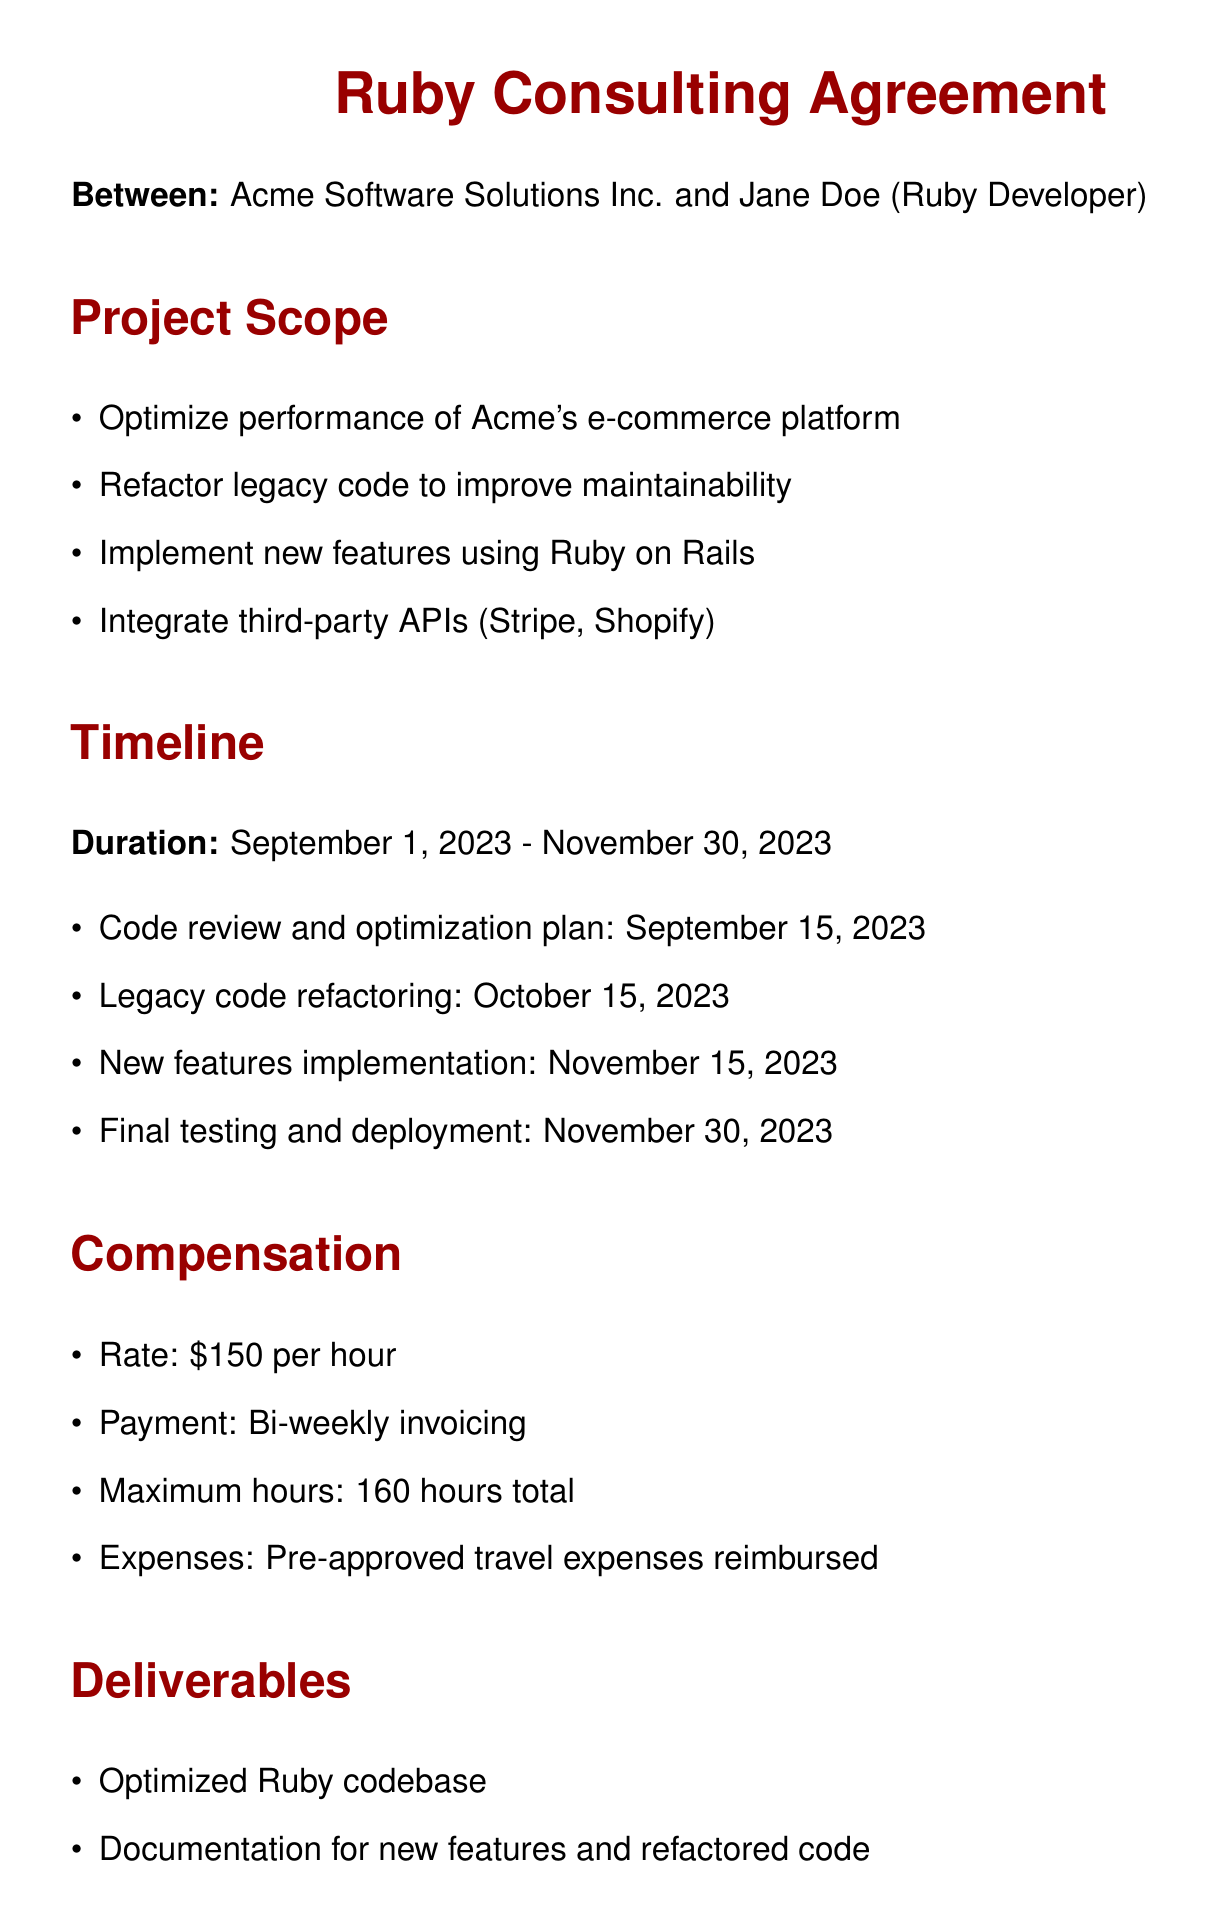What is the name of the consultant? The consultant named in the document is Jane Doe.
Answer: Jane Doe What is the total maximum hours for the consulting gig? The document specifies a maximum of 160 hours total.
Answer: 160 hours When does the project start? The timeline indicates that the project starts on September 1, 2023.
Answer: September 1, 2023 What is the hourly rate for the consultant? The agreed rate for the consulting work is $150 per hour.
Answer: $150 What is one of the key deliverables from the consultant? One of the deliverables mentioned is the optimized Ruby codebase.
Answer: Optimized Ruby codebase What is the latest date for final testing and deployment? The final testing and deployment is scheduled for November 30, 2023.
Answer: November 30, 2023 Who must approve travel expenses? The document states that travel expenses must be pre-approved.
Answer: Pre-approved What is the confidentiality requirement stated in the agreement? The consultant must maintain confidentiality of Acme's proprietary information.
Answer: Confidentiality What should Jane Doe provide each week? Jane Doe is required to submit weekly progress reports.
Answer: Weekly progress reports 